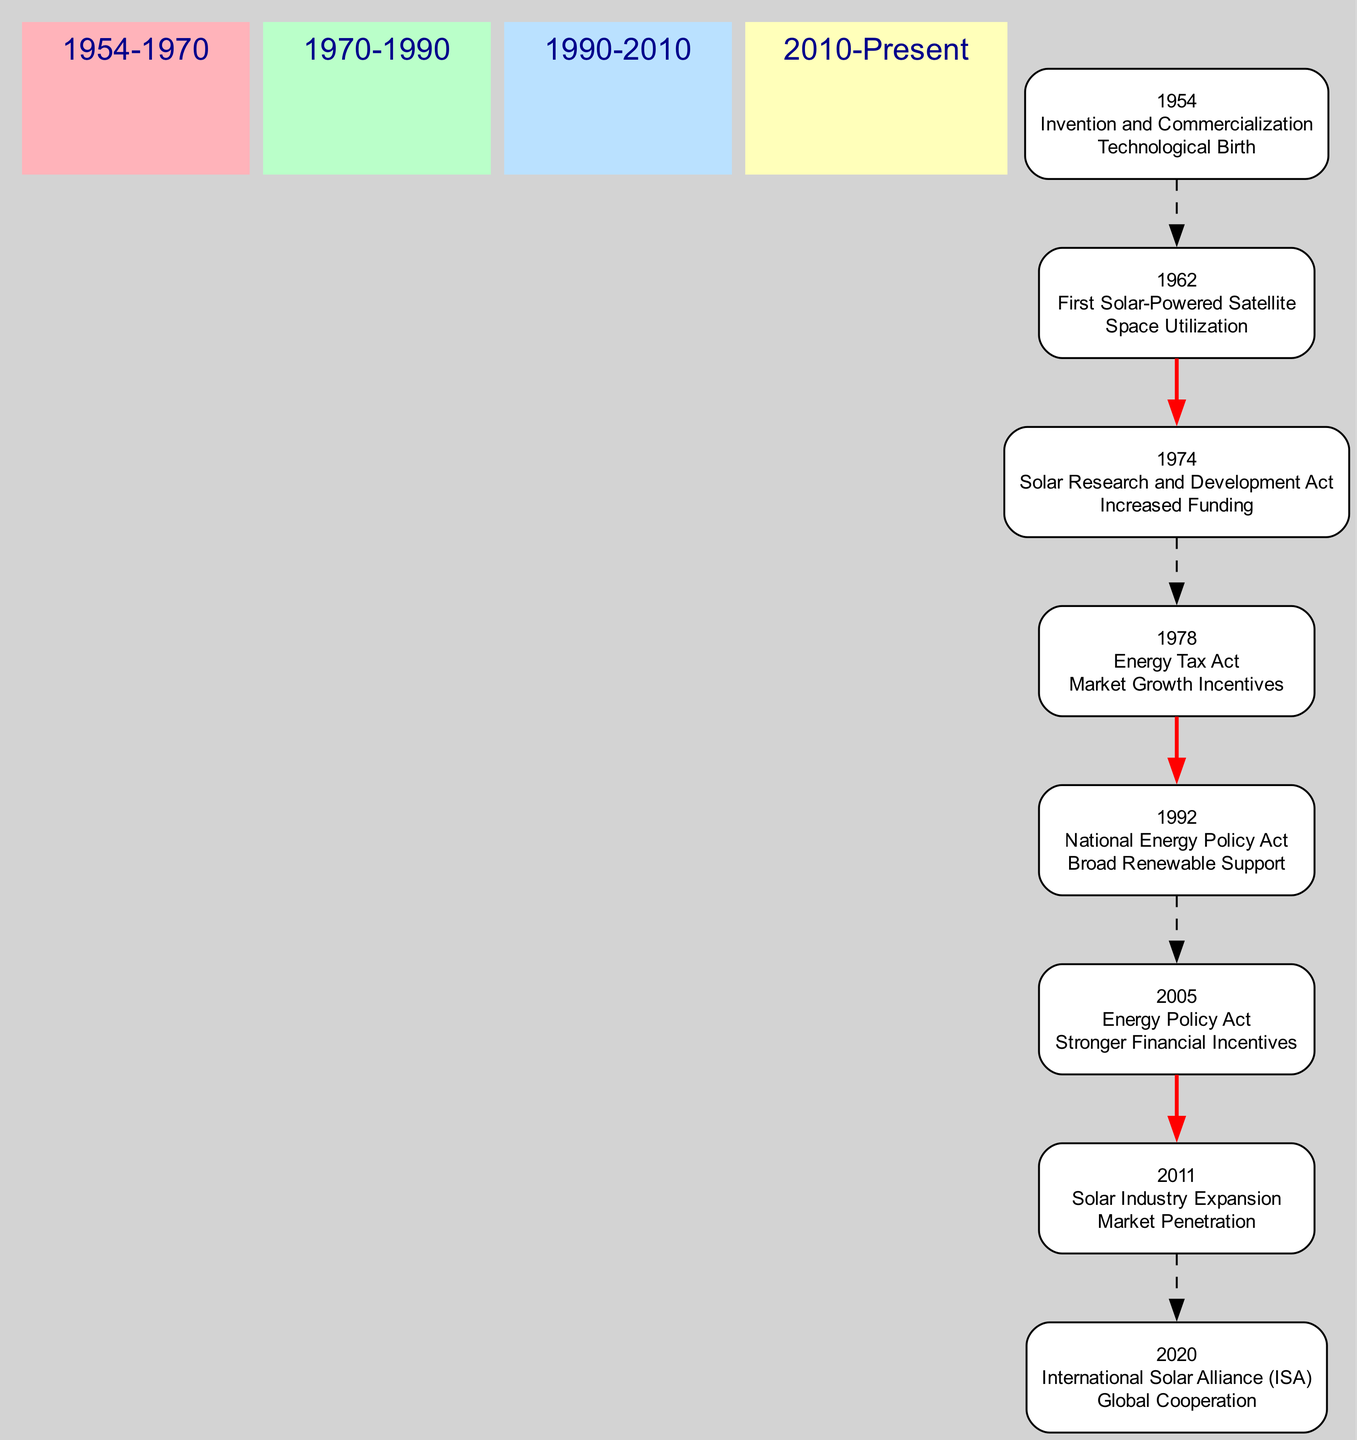What major act was passed in 1974? The diagram indicates that the Solar Research and Development Act was enacted in 1974 to promote solar energy. This is clearly labeled under the 1970-1990 period.
Answer: Solar Research and Development Act Which event had the impact of "Global Cooperation"? According to the diagram, the event described as the International Solar Alliance (ISA) in 2020 is associated with the impact "Global Cooperation." This can be found in the most recent time period.
Answer: International Solar Alliance How many key legislations are mentioned in the 1990-2010 period? By counting the events listed under the 1990-2010 section of the diagram, there are two key legislations: National Energy Policy Act (1992) and Energy Policy Act (2005).
Answer: 2 What is the impact of the "Energy Tax Act"? The diagram specifically states that the impact of the Energy Tax Act, introduced in 1978, is "Market Growth Incentives," which is clearly noted in its description.
Answer: Market Growth Incentives Which year includes an event related to solar technology in space? The diagram details that the year 1962 features the event of NASA launching Telstar, the first solar-powered satellite, illustrating its space application. This event falls within the 1954-1970 time frame.
Answer: 1962 What connects the events in the 1970-1990 period to the 1990-2010 period? The diagram shows a dashed connection between the last event of the 1970-1990 period and the first event of the 1990-2010 period to signify their chronological relationship. The event from 1974 leads to the 1992 event.
Answer: Dashed Connection Which period has no specific legislation associated with its events? The 2010-Present period has an event listed (Solar Industry Expansion in 2011) that states "None" under key legislation, indicating that there were no specific laws passed during that time.
Answer: 2010-Present How does the "Energy Policy Act" in 2005 improve solar energy incentives? The diagram identifies that the 2005 Energy Policy Act introduced the investment tax credit, which offers stronger financial incentives for solar energy systems, thereby enhancing financial support for the sector.
Answer: Stronger Financial Incentives 